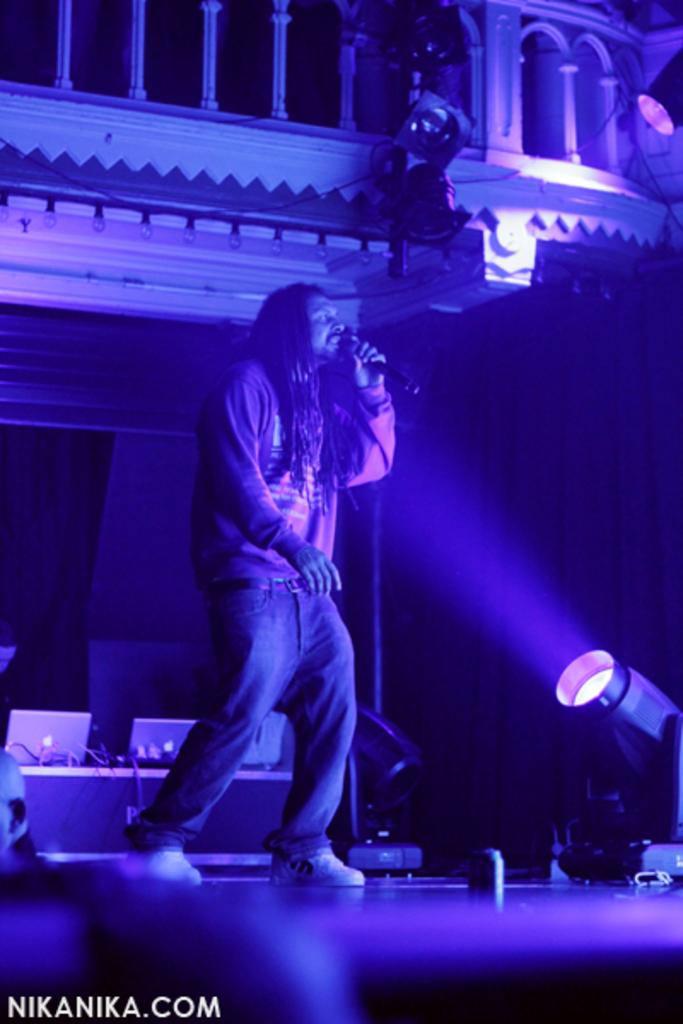What is the person in the image holding? The person in the image is holding a mic. What can be seen in the image that might be used for illumination? Focusing lights, bulbs, and laptops are present in the image, which might be used for illumination. What type of window treatment is visible in the image? There are curtains in the image. What architectural feature can be seen in the image? Railing is visible in the image. What is present in the image that might be used for displaying information or presentations? Laptops are present in the image. Where is the toothbrush located in the image? There is no toothbrush present in the image. Is the person in the image using a skate to hold the mic? No, the person is not using a skate to hold the mic; they are simply holding it in their hand. 